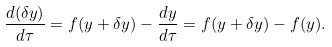Convert formula to latex. <formula><loc_0><loc_0><loc_500><loc_500>\frac { d ( \delta y ) } { d \tau } = f ( y + \delta y ) - \frac { d y } { d \tau } = f ( y + \delta y ) - f ( y ) .</formula> 